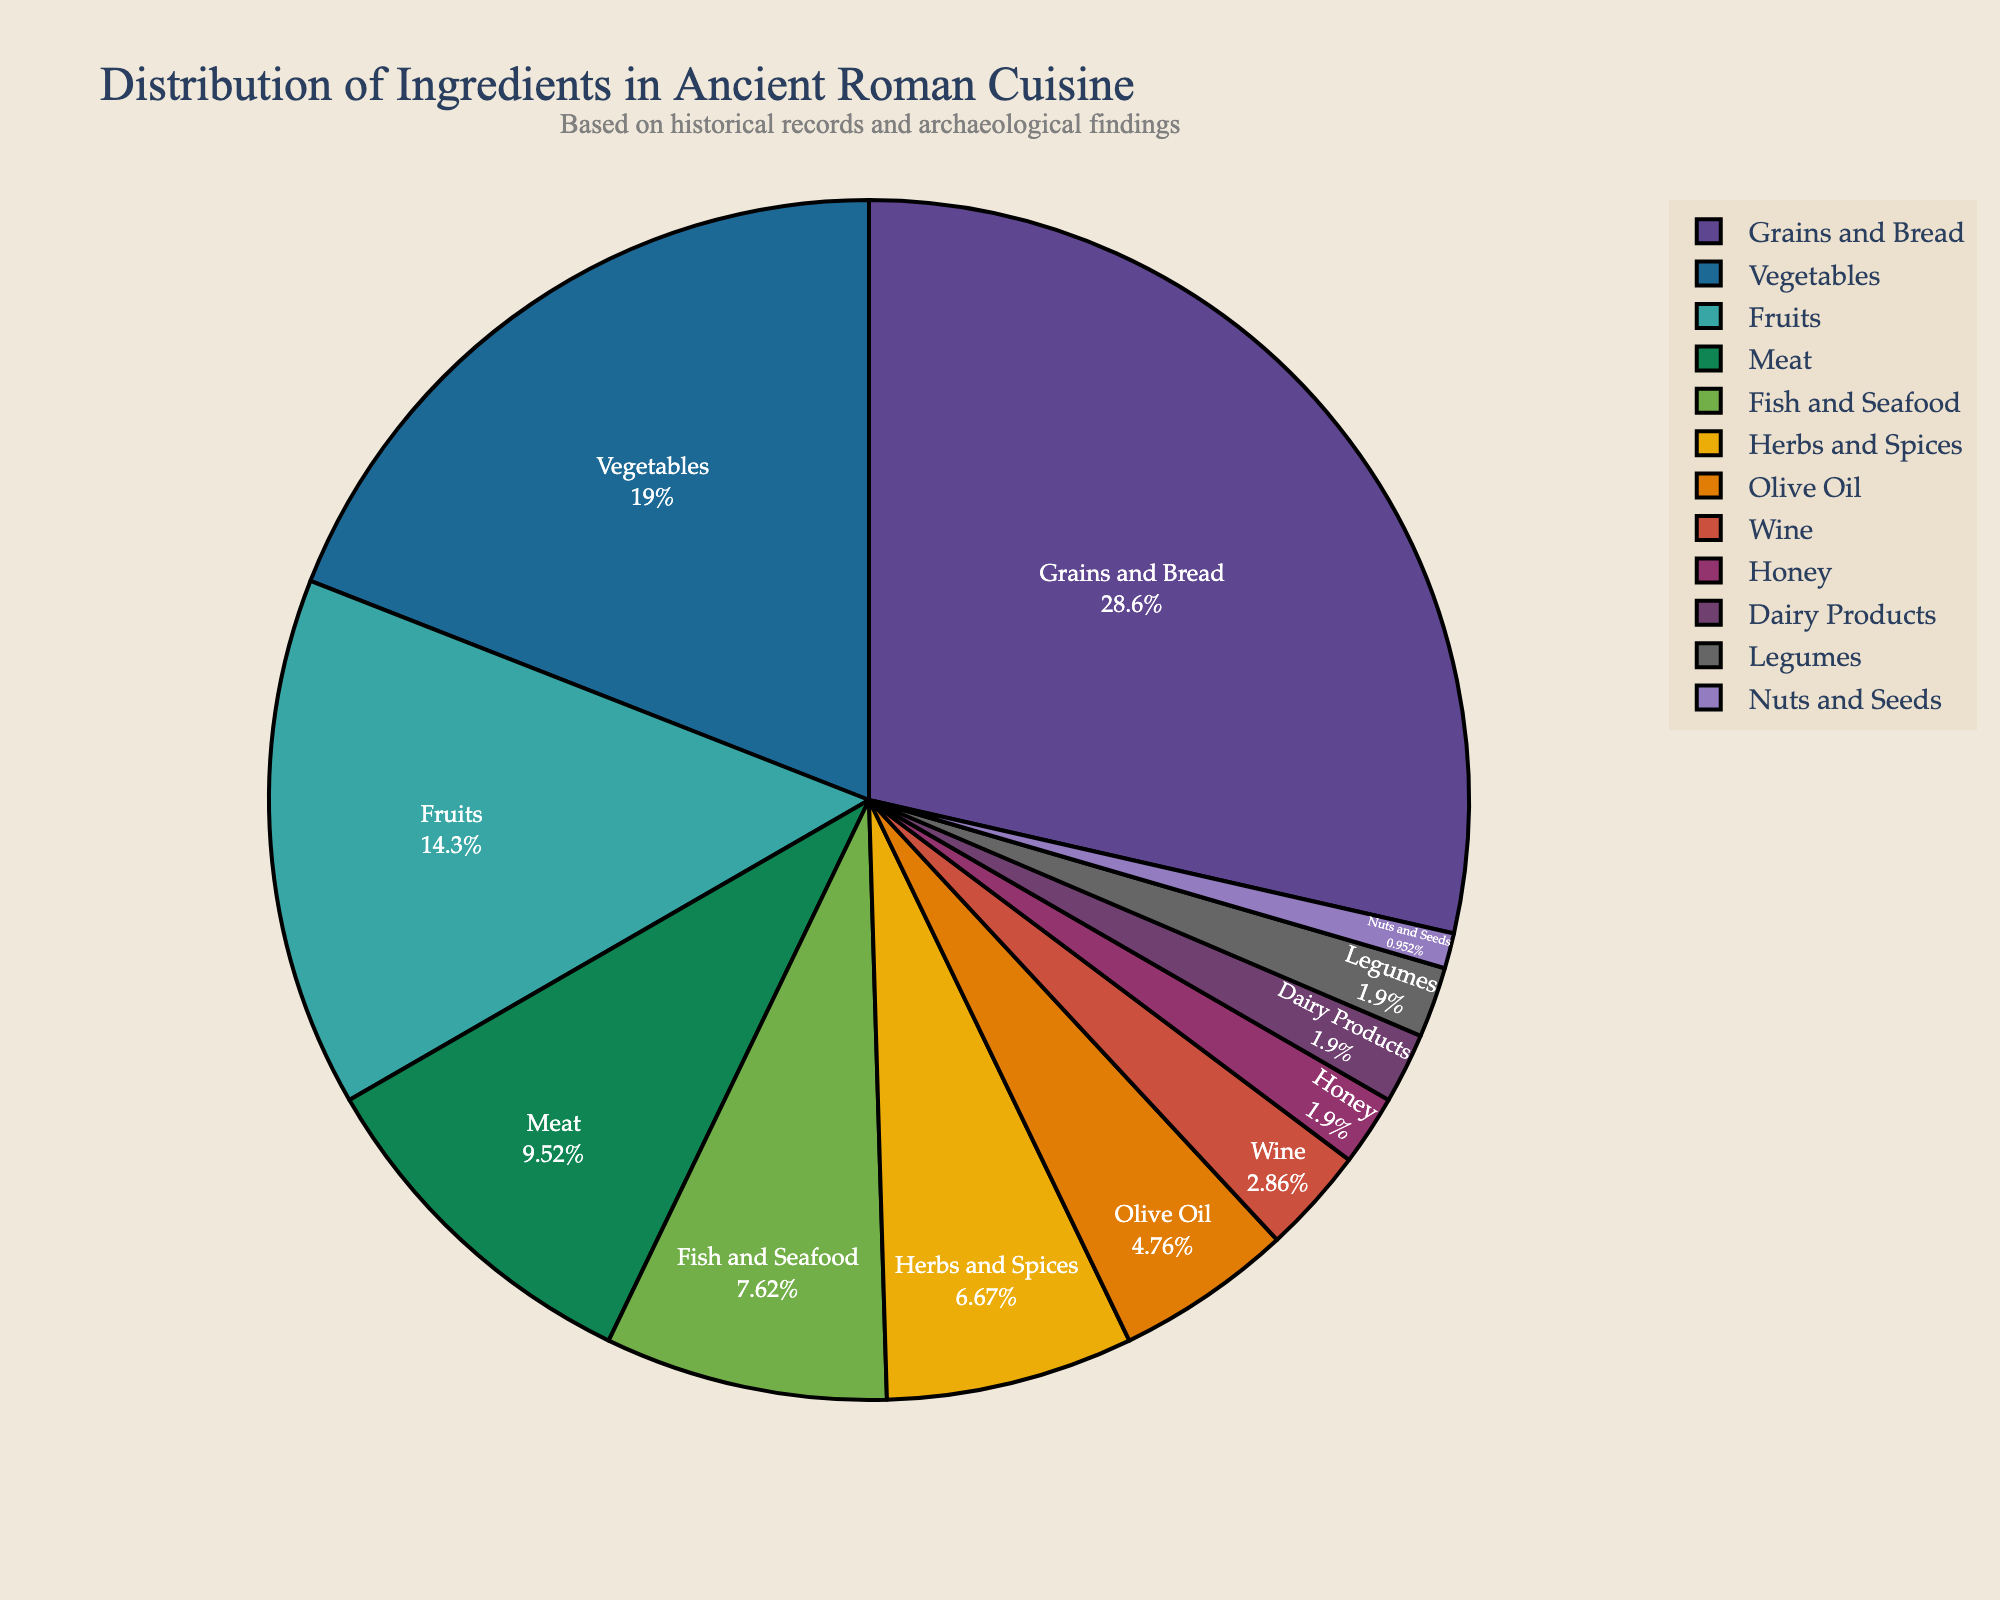What ingredient makes up the largest portion of the pie chart? The slice labeled "Grains and Bread" occupies the largest portion of the pie chart.
Answer: Grains and Bread How much larger, in percentage, is the Grains and Bread slice compared to the Vegetables slice? Grains and Bread is 30%, and Vegetables is 20%. The difference is 30% - 20% = 10%.
Answer: 10% What is the combined percentage of Fruits, Meat, and Fish and Seafood? Fruits is 15%, Meat is 10%, and Fish and Seafood is 8%. Adding them together gives 15% + 10% + 8% = 33%.
Answer: 33% Which ingredient category is closest in percentage to Olive Oil? Olive Oil is 5%, and Herbs and Spices is 7%. Since Herbs and Spices is the nearest in percentage to Olive Oil, this is the answer.
Answer: Herbs and Spices How do the combined percentages of Dairy Products, Legumes, and Nuts and Seeds compare to the percentage of Vegetables? Dairy Products is 2%, Legumes is 2%, and Nuts and Seeds is 1%. Combined, they are 2% + 2% + 1% = 5%. Vegetables is 20%. Therefore, 5% is significantly less than 20%.
Answer: Less than What percentage of ingredients are not from plant-based sources? Meat (10%), Fish and Seafood (8%), and Dairy Products (2%) add up to 10% + 8% + 2% = 20%.
Answer: 20% What portion of the pie chart is taken up by ingredients used as seasonings (Herbs and Spices, Olive Oil, and Honey)? Herbs and Spices is 7%, Olive Oil is 5%, and Honey is 2%. Combined, they account for 7% + 5% + 2% = 14%.
Answer: 14% Which ingredient has the smallest representation in the pie chart? The smallest slice in the pie chart is labeled "Nuts and Seeds" at 1%.
Answer: Nuts and Seeds How much greater is the percentage of Herbs and Spices compared to Wine? Herbs and Spices is 7%, while Wine is 3%. The difference is 7% - 3% = 4%.
Answer: 4% If the total percentage of grains and bread were to be reduced by half, what would its new percentage be? Currently, Grains and Bread is 30%. Halving this would give 30% / 2 = 15%.
Answer: 15% 